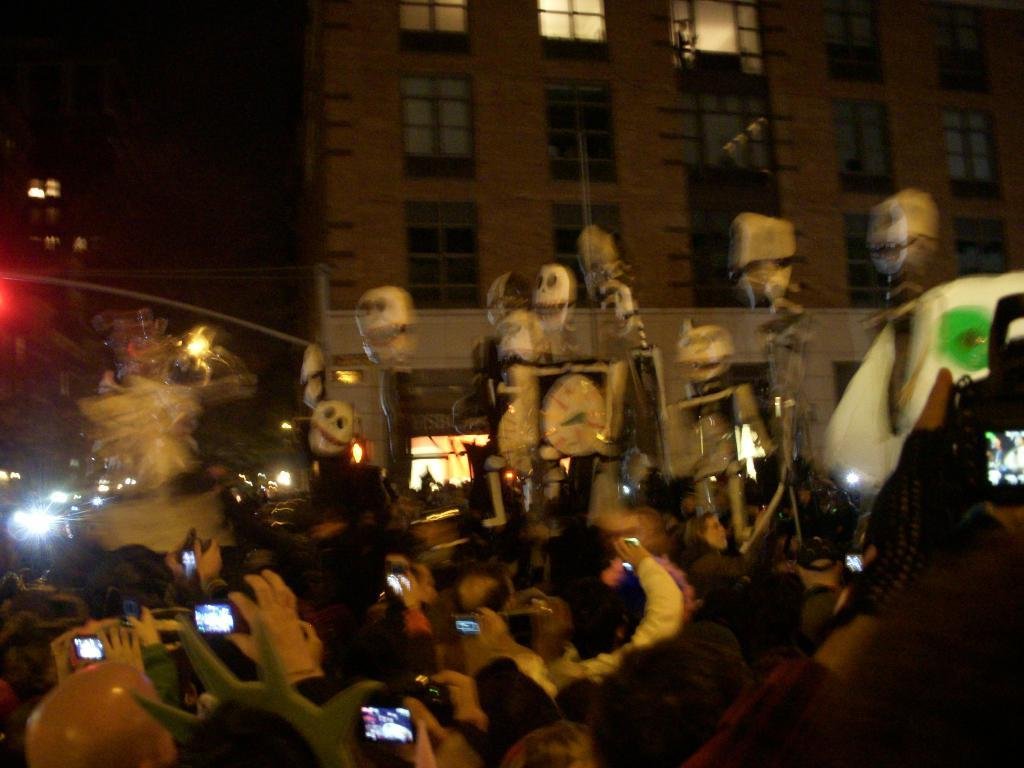What is the main subject of the image? The main subject of the image is a group of persons in the center. What can be seen in the background of the image? There is a building in the background of the image. What feature of the building is mentioned in the facts? The building has windows. What is the income of the persons in the image? There is no information about the income of the persons in the image. 